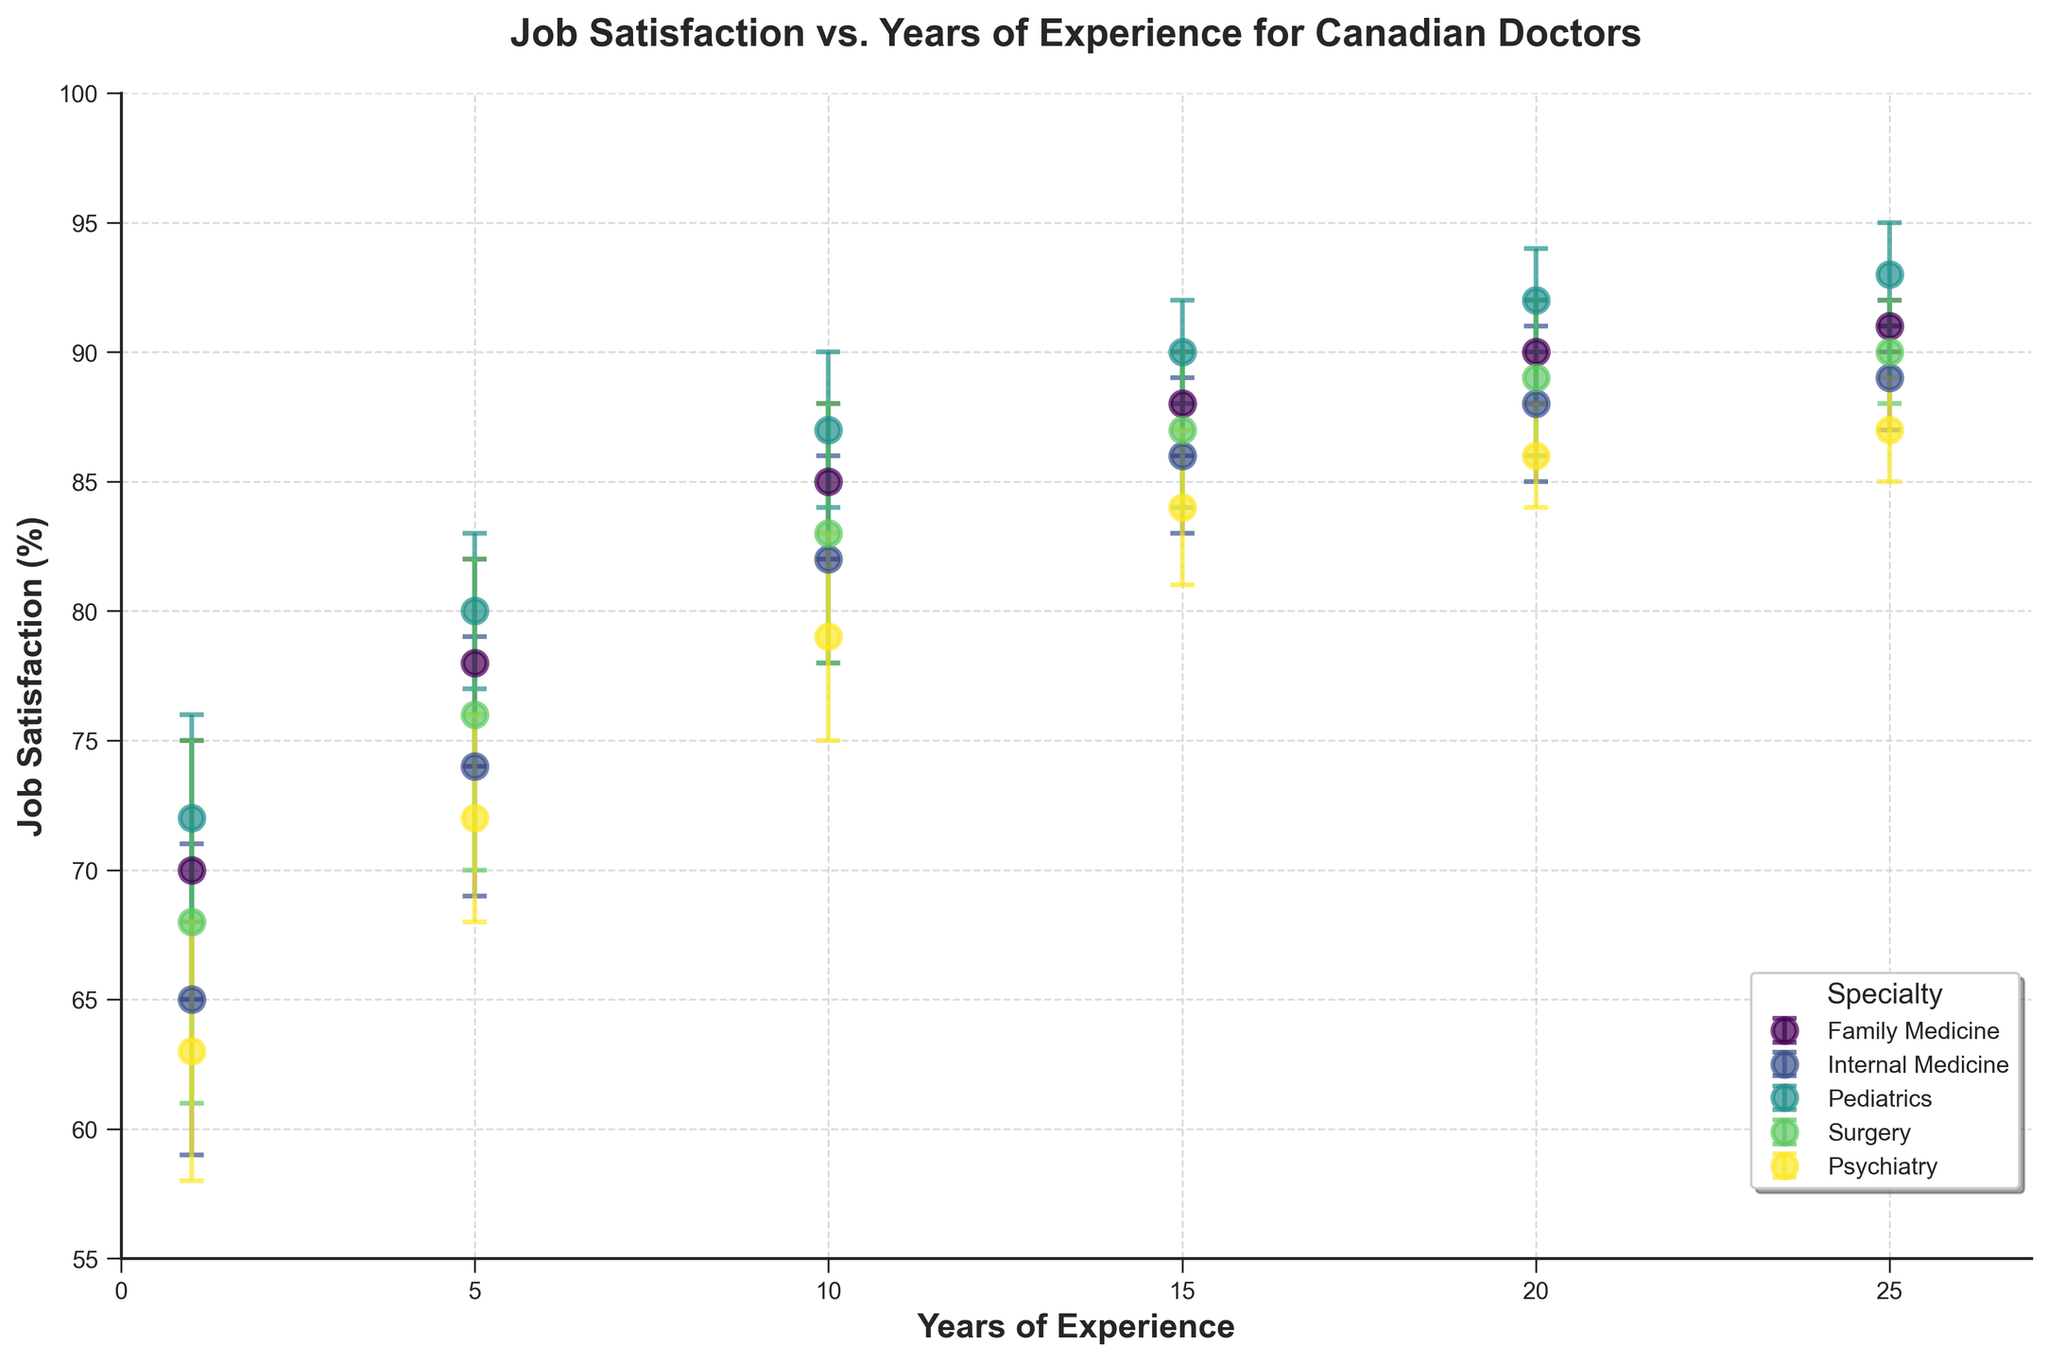What is the title of the figure? The title is displayed at the top center of the figure.
Answer: Job Satisfaction vs. Years of Experience for Canadian Doctors What does the y-axis represent in the figure? The label on the y-axis indicates what it represents.
Answer: Job Satisfaction (%) Which specialty has the highest job satisfaction among doctors with 1 year of experience? Look for the highest job satisfaction value among doctors with 1 year of experience and identify the corresponding specialty.
Answer: Pediatrics What is the average job satisfaction for doctors with 10 years of experience? Add the job satisfaction values for doctors with 10 years of experience and divide by the number of data points. (85 + 82 + 87 + 83 + 79) / 5 = 416 / 5 = 83.2
Answer: 83.2 Do doctors with more years of experience generally report higher job satisfaction? Visually assess the trend of job satisfaction points as years of experience increase.
Answer: Yes Which specialty shows the least variability in job satisfaction with 25 years of experience? Identify which specialty has the smallest error bar among doctors with 25 years of experience.
Answer: Family Medicine How does the job satisfaction of Internal Medicine specialists compare to Pediatricians after 20 years of experience? Compare the job satisfaction values of Internal Medicine and Pediatrics for 20 years of experience.
Answer: Pediatrics is higher At 15 years of experience, is the job satisfaction of Surgeons higher than that of Psychiatrists? Compare the job satisfaction values for Surgery and Psychiatry specialties at 15 years of experience.
Answer: Yes What is the range of job satisfaction for Family Medicine doctors over all years of experience? Identify the minimum and maximum job satisfaction values for Family Medicine doctors and subtract the minimum from the maximum. Range = 91 - 70 = 21
Answer: 21 Which specialty has the most consistent job satisfaction trend across all years of experience? Evaluate the consistency of the job satisfaction trend lines for each specialty across all years of experience.
Answer: Pediatrics 